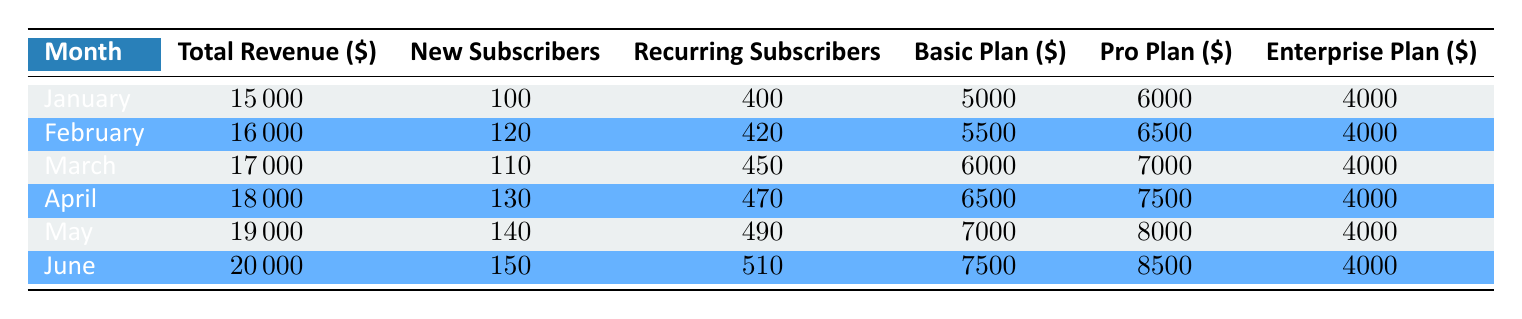What was the total revenue in March? The total revenue for March is directly listed in the table under the "Total Revenue" column for that month. It reads 17000.
Answer: 17000 How many new subscribers were added in April? The number of new subscribers for April is found in the "New Subscribers" column for that month, which shows 130.
Answer: 130 What is the total revenue for the first quarter (January to March)? To find the total revenue for the first quarter, sum the revenues for January (15000), February (16000), and March (17000): 15000 + 16000 + 17000 = 48000.
Answer: 48000 Did the number of recurring subscribers increase from January to June? From the table, January has 400 recurring subscribers. June has 510. Since 510 is greater than 400, this indicates an increase.
Answer: Yes What is the average churn rate for the first half of the year? The churn rates for the first half of the year are: January (5), February (4.5), March (4.2), April (4), May (3.8), and June (3.5). Add them: 5 + 4.5 + 4.2 + 4 + 3.8 + 3.5 = 25. Then divide by 6 (number of months): 25 / 6 = 4.17.
Answer: 4.17 How much revenue did the Pro plan generate in May? The revenue generated by the Pro plan in May is shown in the "Pro Plan" column for that month, which is listed as 8000.
Answer: 8000 What was the difference in total revenue between January and June? The total revenue for January is 15000 and for June is 20000. To find the difference, subtract January's revenue from June's: 20000 - 15000 = 5000.
Answer: 5000 How many total subscribers were there in February? In February, the total number of subscribers is the sum of new and recurring subscribers: 120 new + 420 recurring = 540 total subscribers.
Answer: 540 Was the revenue from the Basic plan higher in any month than from the Enterprise plan? Comparing the Basic plan revenue to the Enterprise plan revenue across all months, in every month the Basic plan had higher revenue (starting from 5000 for Basic in January up to 7500 in June) compared to a constant 4000 from Enterprise.
Answer: Yes 